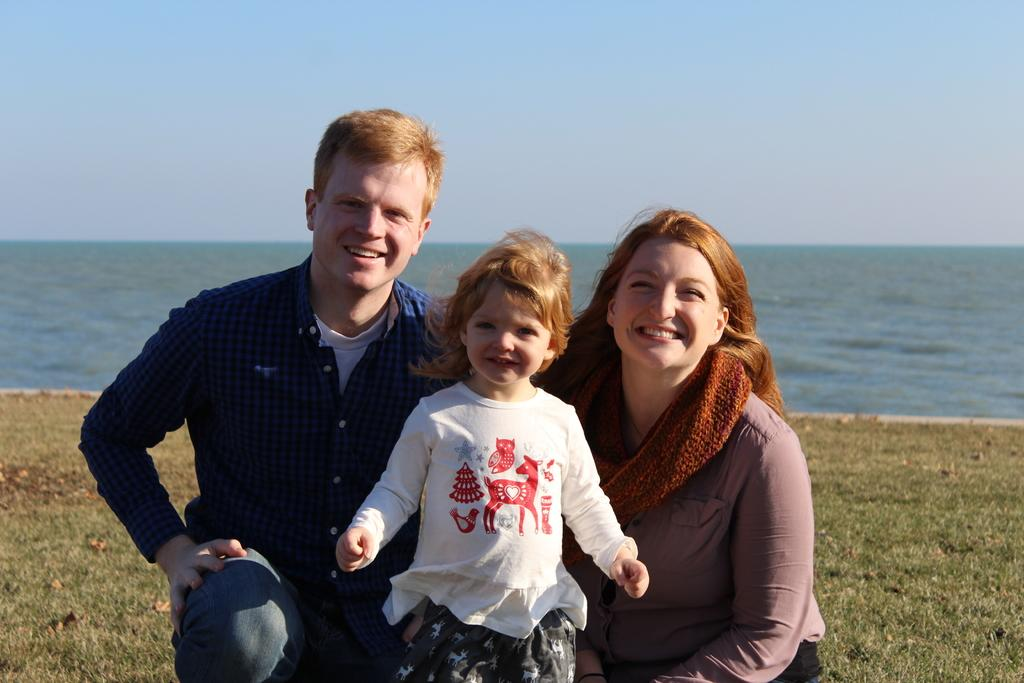How many people are in the foreground of the image? There are three people in the foreground of the image: a man, a woman, and a girl. What are the man and woman doing in the image? The man and woman are squatting on the grass in the image. What is the girl doing in the image? The girl is standing and posing to the camera in the image. What can be seen in the background of the image? Water and the sky are visible in the background of the image. What type of pencil does the dad use to draw in the image? There is no dad present in the image, and no pencil or drawing activity is depicted. 